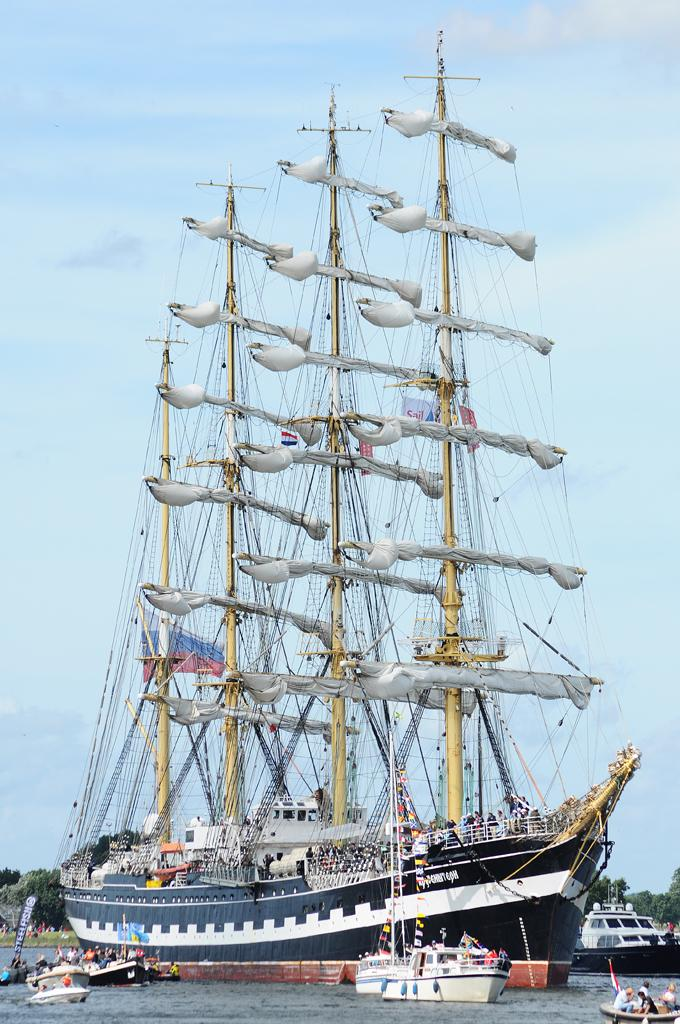<image>
Describe the image concisely. The blue sail has the word steel fish displayed on the front. 